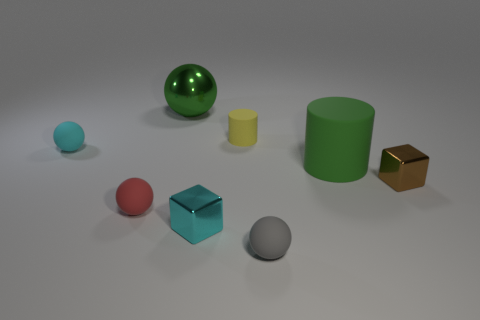How would you describe the texture of the objects in this image? The objects display a variety of textures: the green cylinder and the blue sphere have a matte finish, indicative of a rubbery surface, while the shiny green sphere and the golden cube suggest a smooth, metallic texture. 